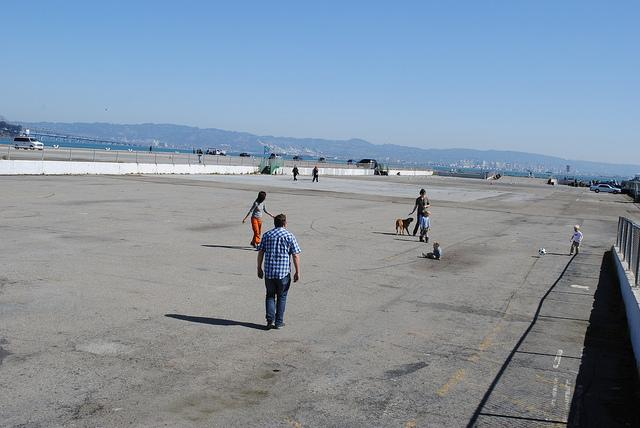What venue is it likely to be? parking lot 